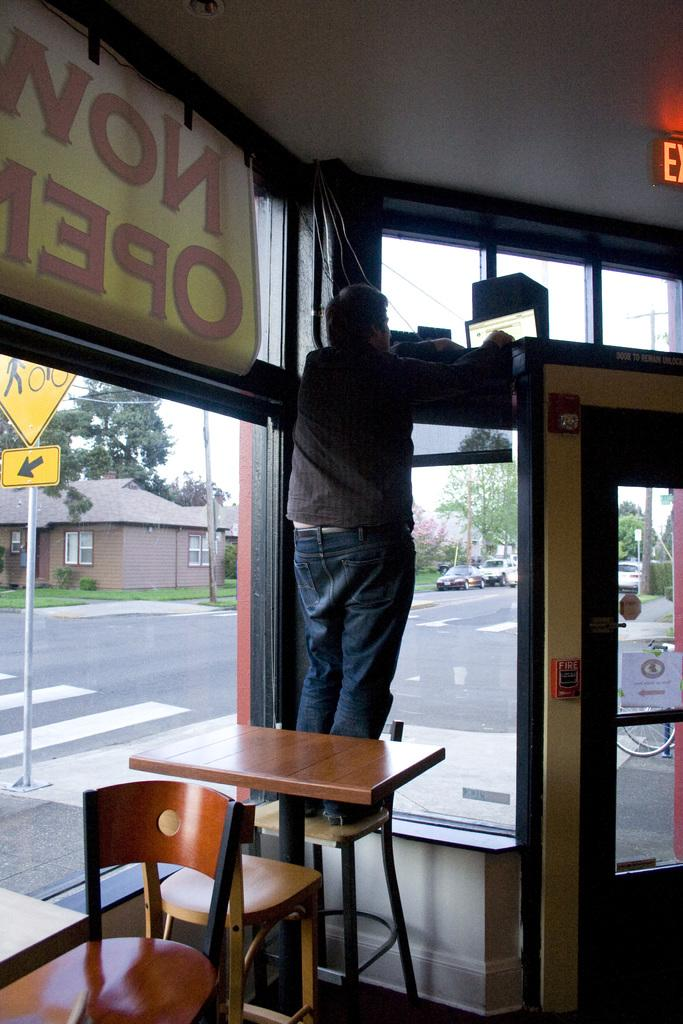What is the person in the image doing? The person is standing on a chair. What is in front of the person? There is a table in front of the person. What can be seen in the background of the image? The image shows a road with many vehicles, buildings, and trees visible near the road. Can you see the ocean in the background of the image? No, the ocean is not visible in the image; it features a road, vehicles, buildings, and trees. 